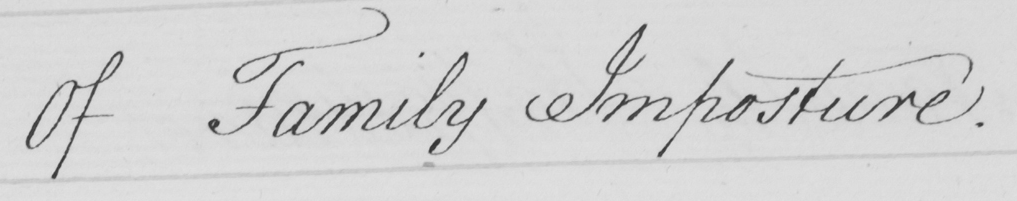What is written in this line of handwriting? Of Family Imposture . 